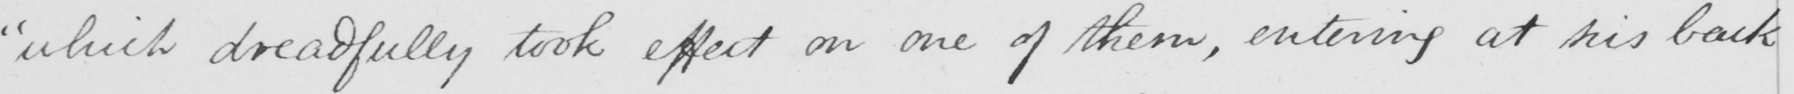What text is written in this handwritten line? " which dreadfully took effect on one of them , entering at his back 